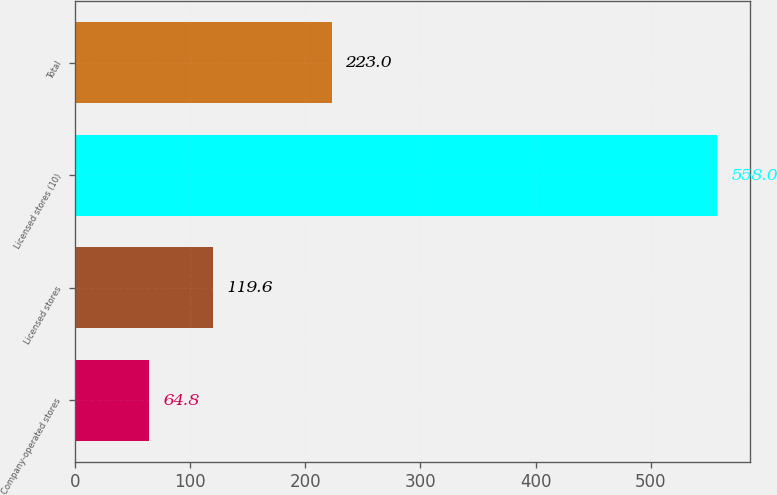<chart> <loc_0><loc_0><loc_500><loc_500><bar_chart><fcel>Company-operated stores<fcel>Licensed stores<fcel>Licensed stores (10)<fcel>Total<nl><fcel>64.8<fcel>119.6<fcel>558<fcel>223<nl></chart> 